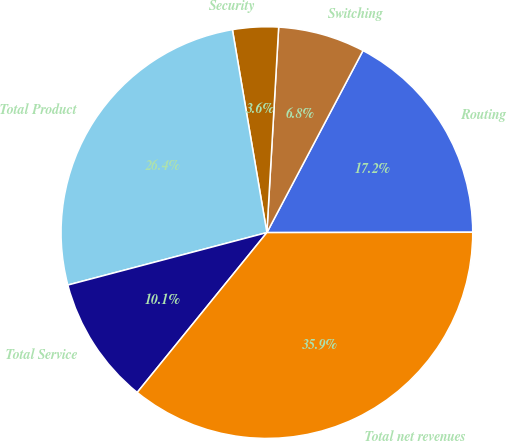Convert chart to OTSL. <chart><loc_0><loc_0><loc_500><loc_500><pie_chart><fcel>Routing<fcel>Switching<fcel>Security<fcel>Total Product<fcel>Total Service<fcel>Total net revenues<nl><fcel>17.24%<fcel>6.82%<fcel>3.59%<fcel>26.42%<fcel>10.05%<fcel>35.87%<nl></chart> 